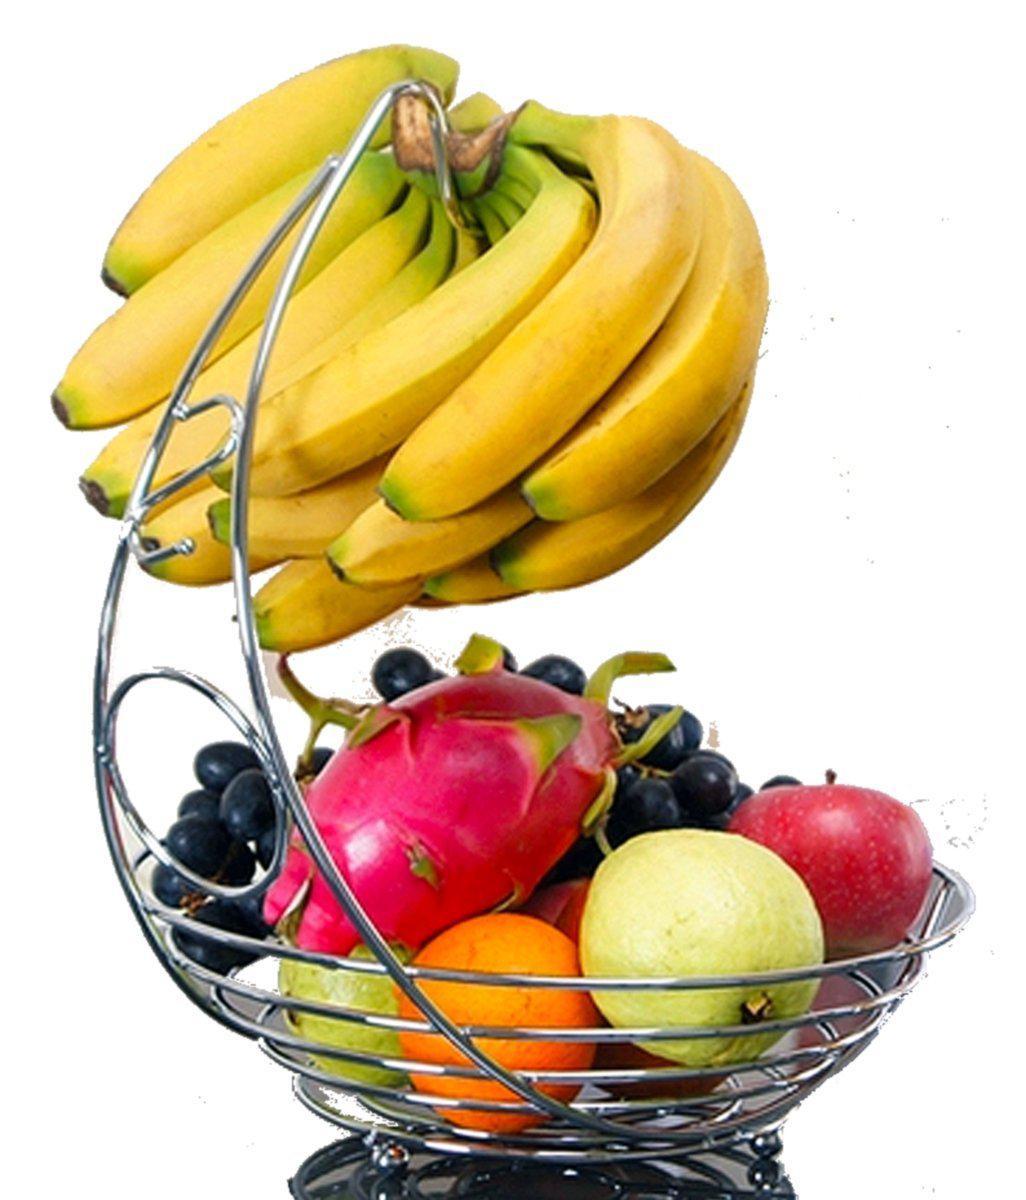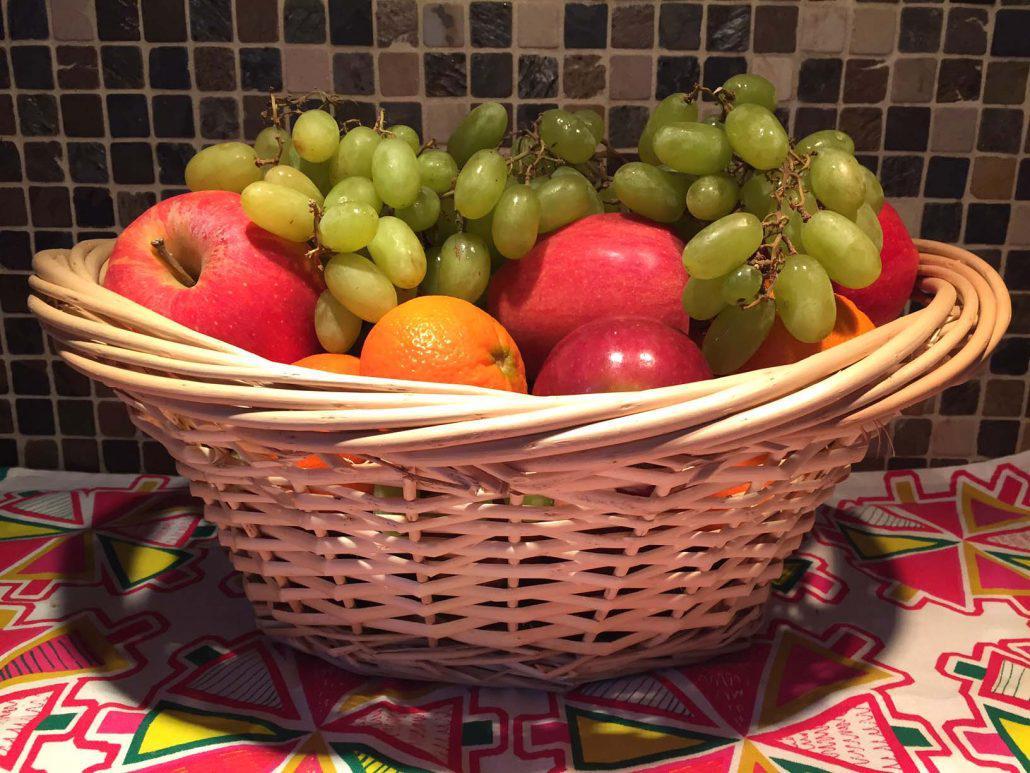The first image is the image on the left, the second image is the image on the right. Evaluate the accuracy of this statement regarding the images: "There are two wicker baskets.". Is it true? Answer yes or no. No. The first image is the image on the left, the second image is the image on the right. Assess this claim about the two images: "Each image features a woven basket filled with a variety of at least three kinds of fruit, and at least one image features a basket with a round handle.". Correct or not? Answer yes or no. No. 